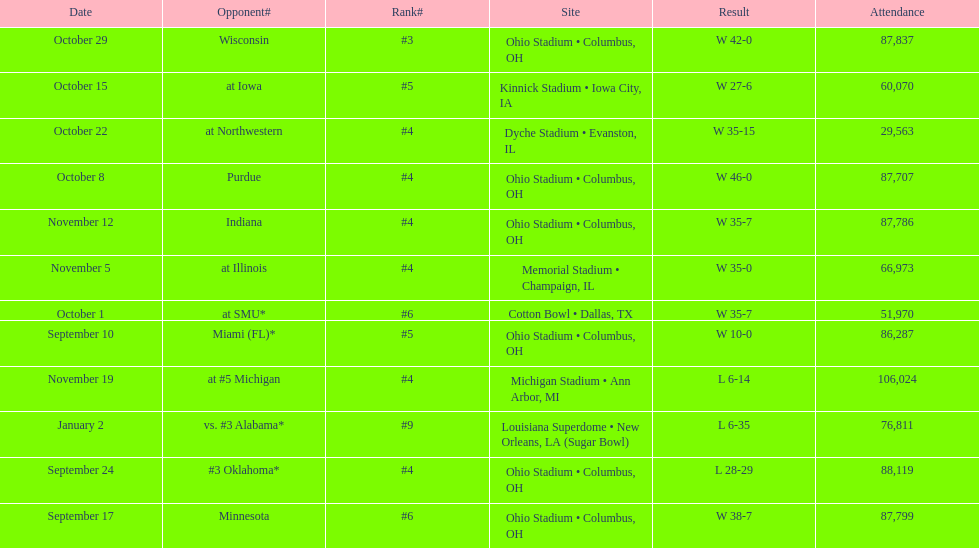What is the disparity between the count of wins and the count of losses? 6. 